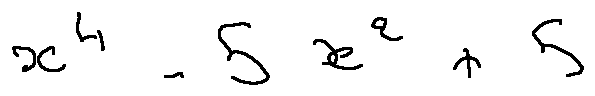<formula> <loc_0><loc_0><loc_500><loc_500>x ^ { 4 } - 5 x ^ { 2 } + 5</formula> 